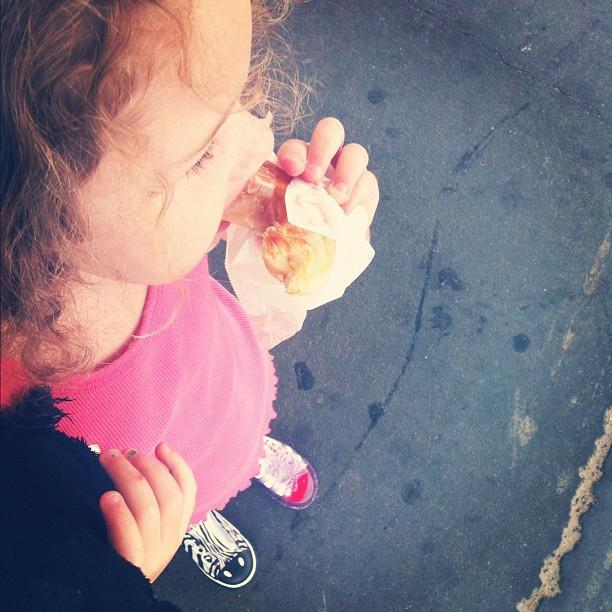What color is one of the girl's shoes? Please explain your reasoning. black. The shoes are black. 